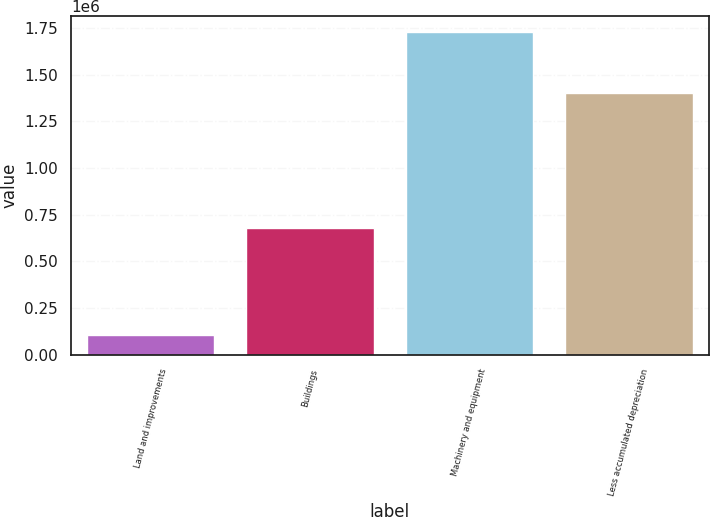Convert chart. <chart><loc_0><loc_0><loc_500><loc_500><bar_chart><fcel>Land and improvements<fcel>Buildings<fcel>Machinery and equipment<fcel>Less accumulated depreciation<nl><fcel>105096<fcel>679575<fcel>1.72643e+06<fcel>1.40246e+06<nl></chart> 